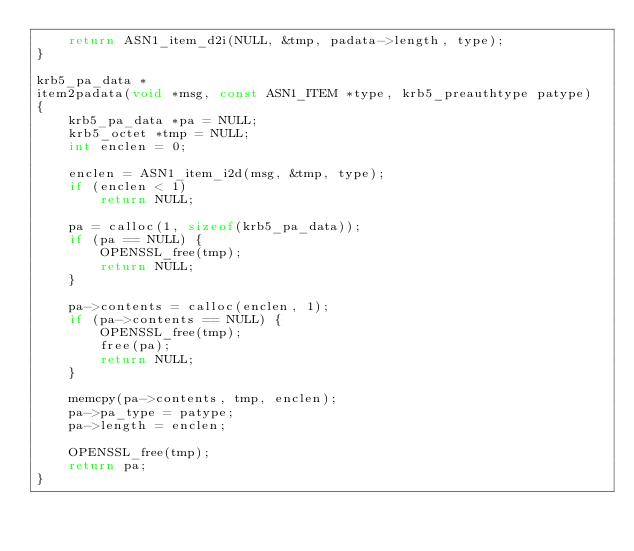Convert code to text. <code><loc_0><loc_0><loc_500><loc_500><_C_>    return ASN1_item_d2i(NULL, &tmp, padata->length, type);
}

krb5_pa_data *
item2padata(void *msg, const ASN1_ITEM *type, krb5_preauthtype patype)
{
    krb5_pa_data *pa = NULL;
    krb5_octet *tmp = NULL;
    int enclen = 0;

    enclen = ASN1_item_i2d(msg, &tmp, type);
    if (enclen < 1)
        return NULL;

    pa = calloc(1, sizeof(krb5_pa_data));
    if (pa == NULL) {
        OPENSSL_free(tmp);
        return NULL;
    }

    pa->contents = calloc(enclen, 1);
    if (pa->contents == NULL) {
        OPENSSL_free(tmp);
        free(pa);
        return NULL;
    }

    memcpy(pa->contents, tmp, enclen);
    pa->pa_type = patype;
    pa->length = enclen;

    OPENSSL_free(tmp);
    return pa;
}
</code> 